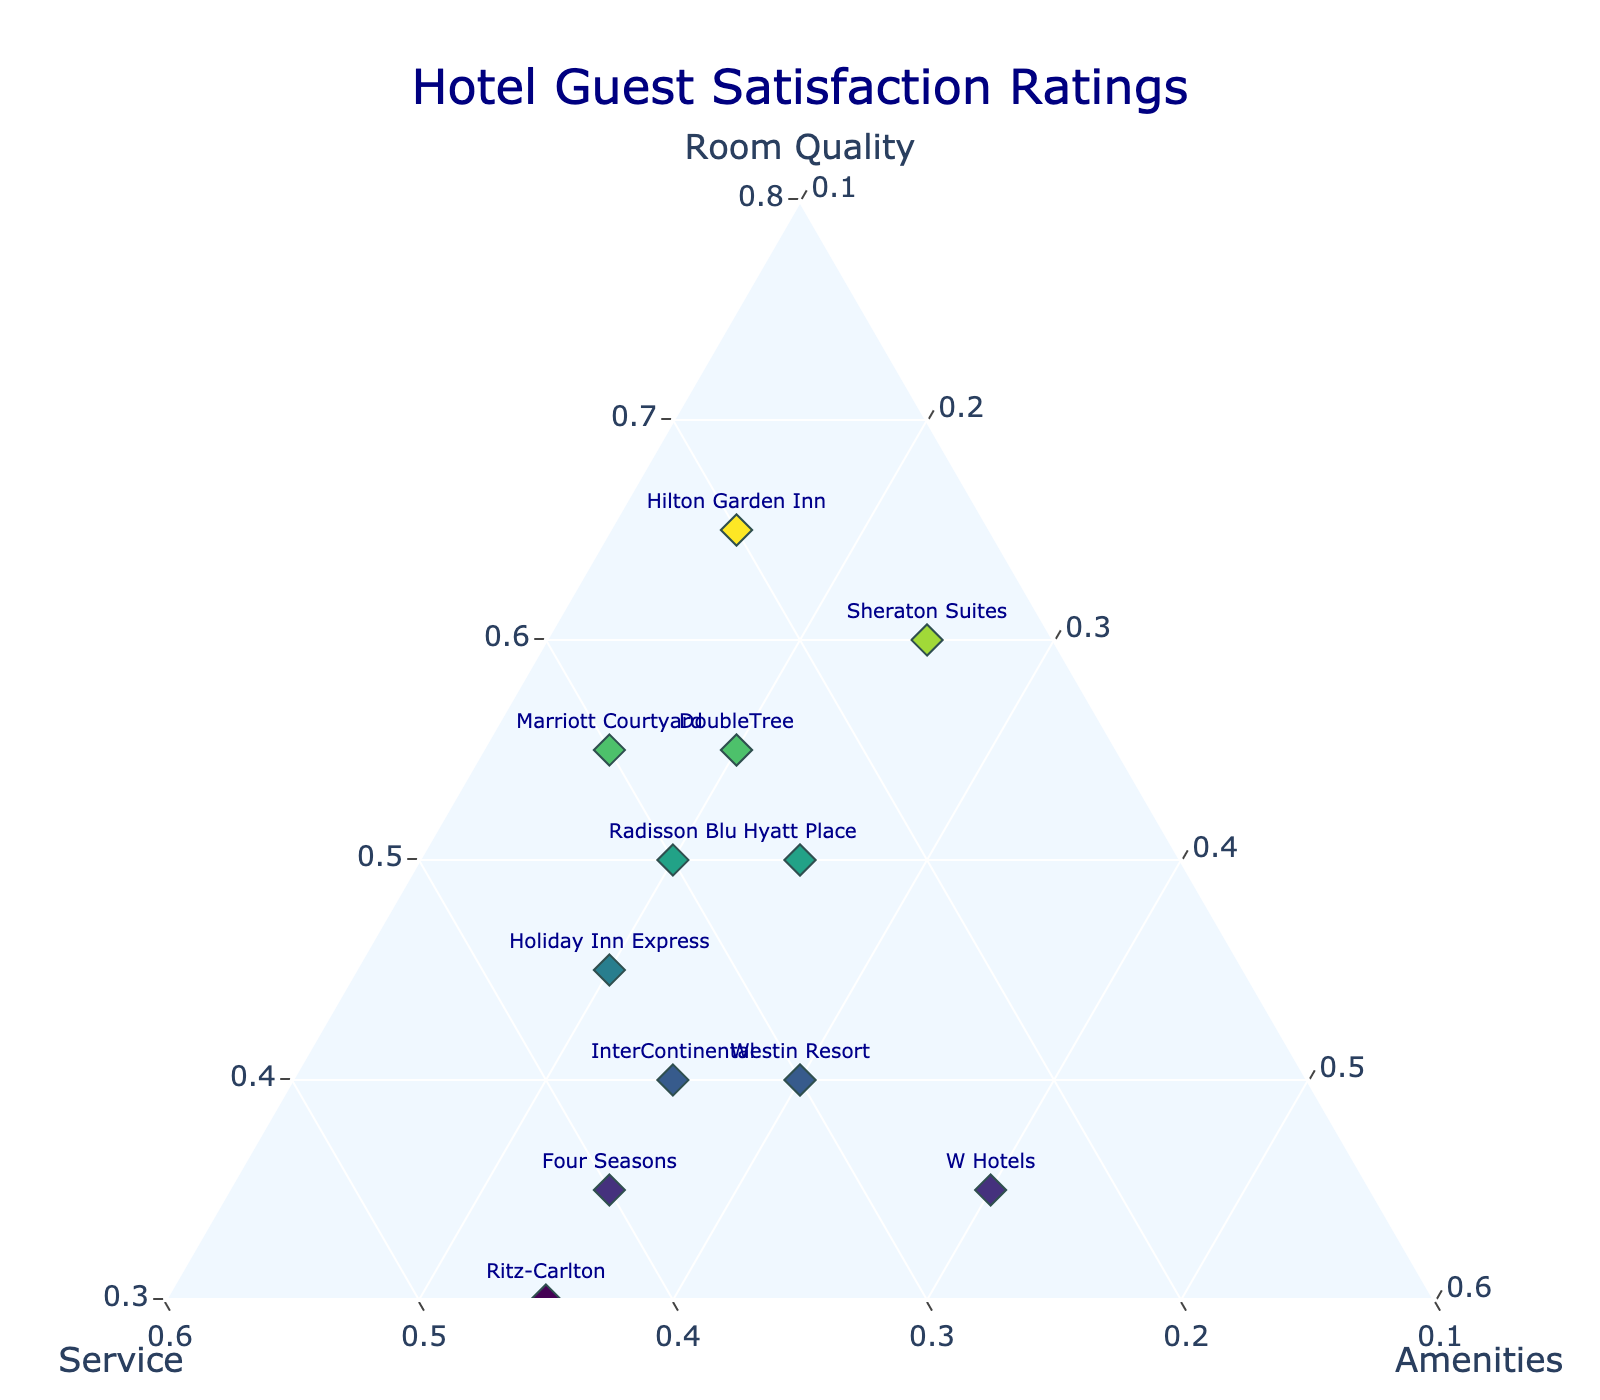What's the title of the plot? The title is displayed at the top of the plot, centered.
Answer: Hotel Guest Satisfaction Ratings Which axis represents room quality? In a ternary plot, the axes are typically labeled. The axis labeled "Room Quality" represents room quality.
Answer: Room Quality How many hotels have more than 35% of their satisfaction from service? We need to count all data points where the "Service" axis value is greater than 0.35. Those hotels are Four Seasons, Ritz-Carlton, and Holiday Inn Express.
Answer: 3 What hotel has equal satisfaction ratings for service and amenities? Look for the hotel where the 'Service' and 'Amenities' values are the same. From the data, Hyatt Place has both values at 0.25.
Answer: Hyatt Place Which hotel prioritizes amenities the most? Find the hotel with the highest value for the "Amenities" axis. W Hotels has the highest amenities satisfaction at 0.40.
Answer: W Hotels Between the Hilton Garden Inn and Marriott Courtyard, which hotel has higher service satisfaction? Compare the 'Service' values of Hilton Garden Inn (0.20) and Marriott Courtyard (0.30). Marriott Courtyard has a higher service satisfaction.
Answer: Marriott Courtyard What's the average satisfaction rating for room quality across all hotels? Sum the room quality values from all hotels and divide by the number of hotels. (0.65+0.55+0.50+0.60+0.45+0.40+0.35+0.30+0.35+0.40+0.50+0.55)/12 = 5.60/12.
Answer: 0.467 Which hotel has the lowest satisfaction rating for room quality? Identify the hotel with the smallest value on the "Room Quality" axis. Ritz-Carlton has the lowest value at 0.30.
Answer: Ritz-Carlton 